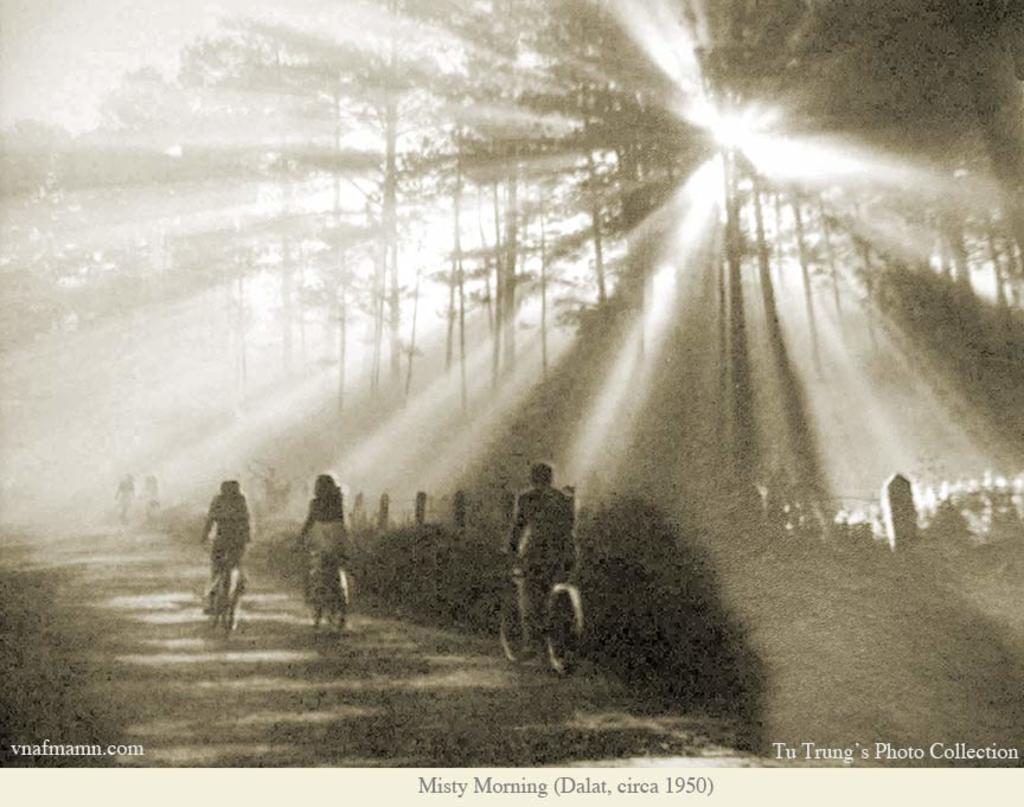How would you summarize this image in a sentence or two? This is a black and white image. In this image we can see a group of people riding bicycles on the pathway. We can also see a fence, plants and a group of trees. On the bottom of the image we can see some text. 